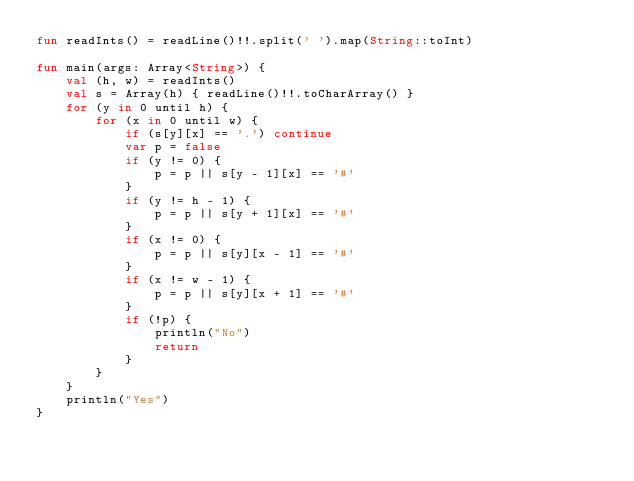<code> <loc_0><loc_0><loc_500><loc_500><_Kotlin_>fun readInts() = readLine()!!.split(' ').map(String::toInt)

fun main(args: Array<String>) {
    val (h, w) = readInts()
    val s = Array(h) { readLine()!!.toCharArray() }
    for (y in 0 until h) {
        for (x in 0 until w) {
            if (s[y][x] == '.') continue
            var p = false
            if (y != 0) {
                p = p || s[y - 1][x] == '#'
            }
            if (y != h - 1) {
                p = p || s[y + 1][x] == '#'
            }
            if (x != 0) {
                p = p || s[y][x - 1] == '#'
            }
            if (x != w - 1) {
                p = p || s[y][x + 1] == '#'
            }
            if (!p) {
                println("No")
                return
            }
        }
    }
    println("Yes")
}
</code> 